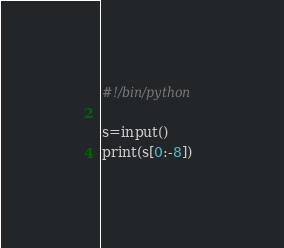<code> <loc_0><loc_0><loc_500><loc_500><_Python_>#!/bin/python

s=input()
print(s[0:-8])
</code> 